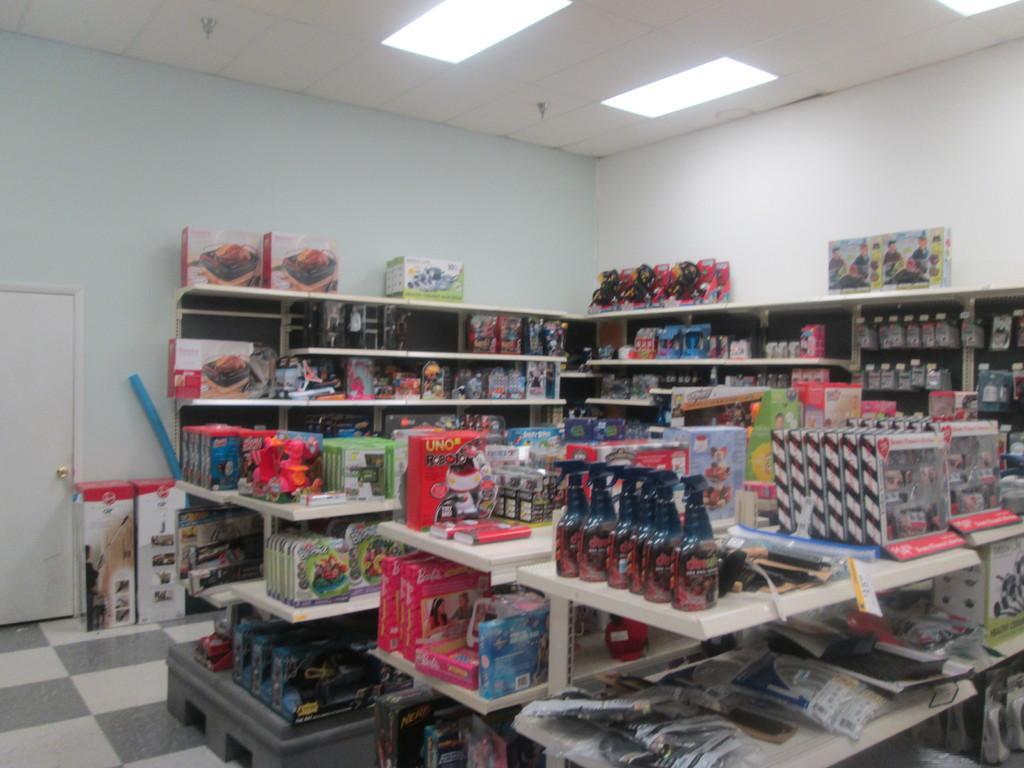Describe this image in one or two sentences. In this picture I can see number of boxes and other things on the racks and I can see the floor on the left side of this image. In the background I can see the wall and I can see a door. On the top of this picture I can see the lights on the ceiling. 